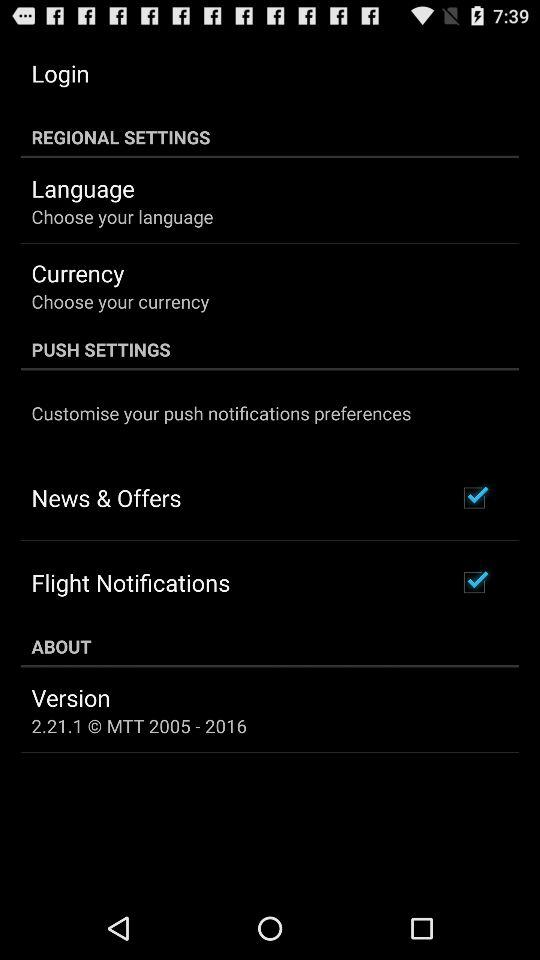What is the status of "News & Offers"? The status is "on". 